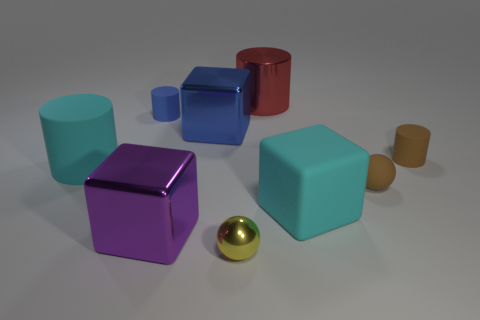Subtract all blue metallic blocks. How many blocks are left? 2 Add 1 cyan spheres. How many objects exist? 10 Subtract all brown cylinders. How many cylinders are left? 3 Subtract 1 blocks. How many blocks are left? 2 Subtract all cylinders. How many objects are left? 5 Subtract 1 purple blocks. How many objects are left? 8 Subtract all purple balls. Subtract all purple cylinders. How many balls are left? 2 Subtract all cyan rubber blocks. Subtract all rubber things. How many objects are left? 3 Add 9 purple things. How many purple things are left? 10 Add 3 yellow metal balls. How many yellow metal balls exist? 4 